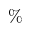<formula> <loc_0><loc_0><loc_500><loc_500>\%</formula> 